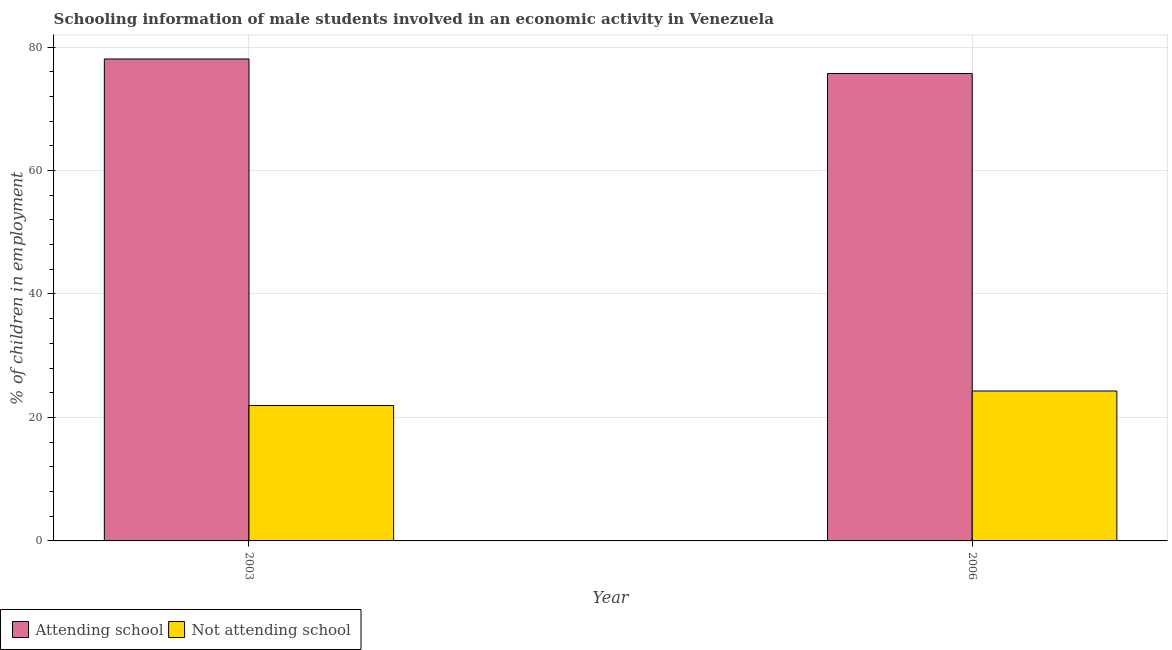How many different coloured bars are there?
Offer a very short reply. 2. How many groups of bars are there?
Your answer should be very brief. 2. Are the number of bars per tick equal to the number of legend labels?
Keep it short and to the point. Yes. What is the label of the 1st group of bars from the left?
Give a very brief answer. 2003. What is the percentage of employed males who are not attending school in 2003?
Give a very brief answer. 21.93. Across all years, what is the maximum percentage of employed males who are not attending school?
Offer a very short reply. 24.29. Across all years, what is the minimum percentage of employed males who are not attending school?
Make the answer very short. 21.93. In which year was the percentage of employed males who are not attending school maximum?
Offer a terse response. 2006. What is the total percentage of employed males who are not attending school in the graph?
Make the answer very short. 46.22. What is the difference between the percentage of employed males who are attending school in 2003 and that in 2006?
Provide a succinct answer. 2.36. What is the difference between the percentage of employed males who are not attending school in 2006 and the percentage of employed males who are attending school in 2003?
Make the answer very short. 2.36. What is the average percentage of employed males who are attending school per year?
Ensure brevity in your answer.  76.89. In the year 2006, what is the difference between the percentage of employed males who are not attending school and percentage of employed males who are attending school?
Offer a terse response. 0. In how many years, is the percentage of employed males who are attending school greater than 4 %?
Your answer should be very brief. 2. What is the ratio of the percentage of employed males who are attending school in 2003 to that in 2006?
Provide a short and direct response. 1.03. What does the 2nd bar from the left in 2003 represents?
Provide a short and direct response. Not attending school. What does the 1st bar from the right in 2006 represents?
Provide a succinct answer. Not attending school. How many bars are there?
Your answer should be very brief. 4. Are the values on the major ticks of Y-axis written in scientific E-notation?
Offer a terse response. No. Does the graph contain any zero values?
Your answer should be compact. No. How many legend labels are there?
Offer a very short reply. 2. How are the legend labels stacked?
Your response must be concise. Horizontal. What is the title of the graph?
Make the answer very short. Schooling information of male students involved in an economic activity in Venezuela. What is the label or title of the Y-axis?
Your answer should be very brief. % of children in employment. What is the % of children in employment in Attending school in 2003?
Offer a very short reply. 78.07. What is the % of children in employment of Not attending school in 2003?
Your response must be concise. 21.93. What is the % of children in employment of Attending school in 2006?
Make the answer very short. 75.71. What is the % of children in employment in Not attending school in 2006?
Your answer should be compact. 24.29. Across all years, what is the maximum % of children in employment of Attending school?
Ensure brevity in your answer.  78.07. Across all years, what is the maximum % of children in employment in Not attending school?
Make the answer very short. 24.29. Across all years, what is the minimum % of children in employment in Attending school?
Offer a terse response. 75.71. Across all years, what is the minimum % of children in employment in Not attending school?
Keep it short and to the point. 21.93. What is the total % of children in employment in Attending school in the graph?
Your answer should be very brief. 153.78. What is the total % of children in employment in Not attending school in the graph?
Offer a very short reply. 46.22. What is the difference between the % of children in employment of Attending school in 2003 and that in 2006?
Make the answer very short. 2.36. What is the difference between the % of children in employment of Not attending school in 2003 and that in 2006?
Give a very brief answer. -2.36. What is the difference between the % of children in employment of Attending school in 2003 and the % of children in employment of Not attending school in 2006?
Give a very brief answer. 53.78. What is the average % of children in employment in Attending school per year?
Keep it short and to the point. 76.89. What is the average % of children in employment of Not attending school per year?
Offer a very short reply. 23.11. In the year 2003, what is the difference between the % of children in employment of Attending school and % of children in employment of Not attending school?
Provide a short and direct response. 56.14. In the year 2006, what is the difference between the % of children in employment of Attending school and % of children in employment of Not attending school?
Offer a very short reply. 51.43. What is the ratio of the % of children in employment in Attending school in 2003 to that in 2006?
Offer a very short reply. 1.03. What is the ratio of the % of children in employment of Not attending school in 2003 to that in 2006?
Your answer should be compact. 0.9. What is the difference between the highest and the second highest % of children in employment of Attending school?
Provide a succinct answer. 2.36. What is the difference between the highest and the second highest % of children in employment of Not attending school?
Your answer should be compact. 2.36. What is the difference between the highest and the lowest % of children in employment of Attending school?
Your response must be concise. 2.36. What is the difference between the highest and the lowest % of children in employment of Not attending school?
Ensure brevity in your answer.  2.36. 